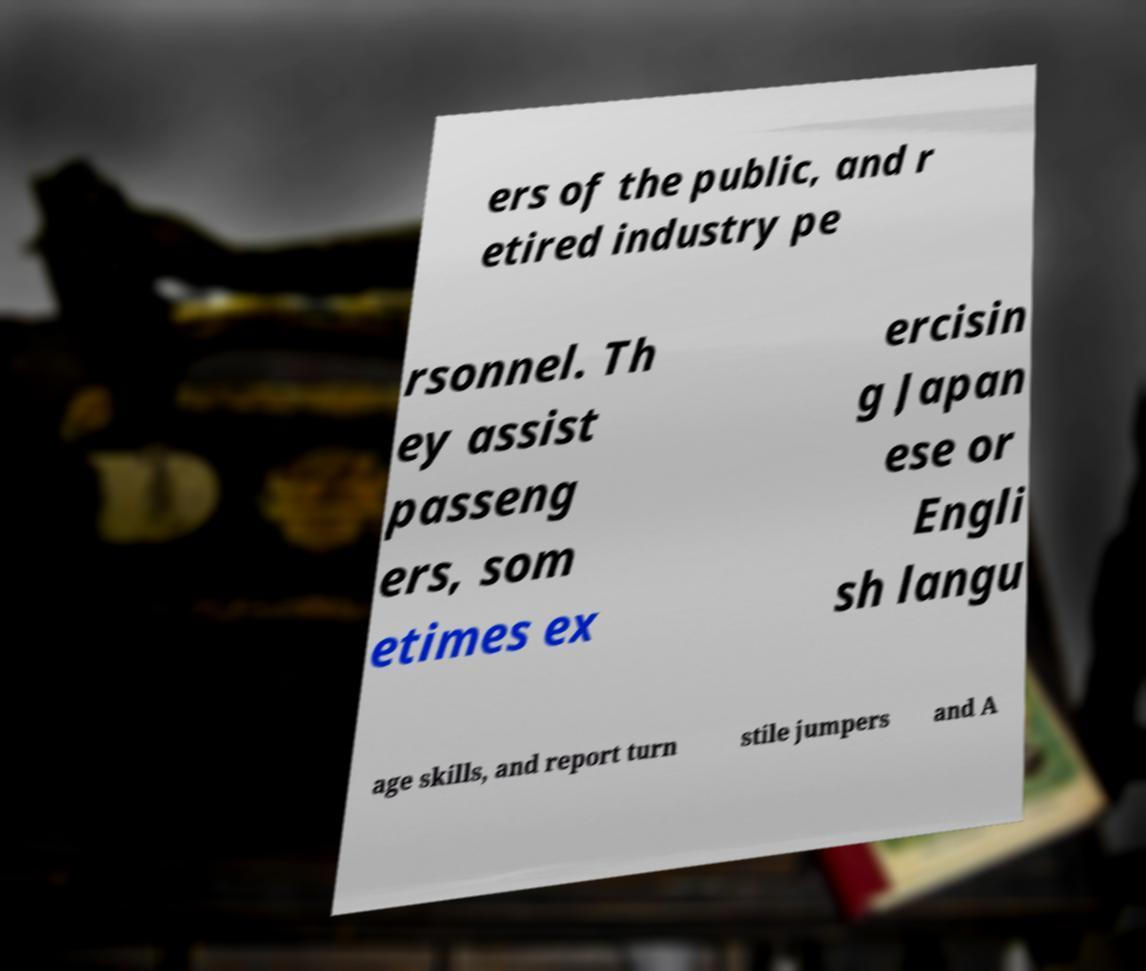Could you assist in decoding the text presented in this image and type it out clearly? ers of the public, and r etired industry pe rsonnel. Th ey assist passeng ers, som etimes ex ercisin g Japan ese or Engli sh langu age skills, and report turn stile jumpers and A 